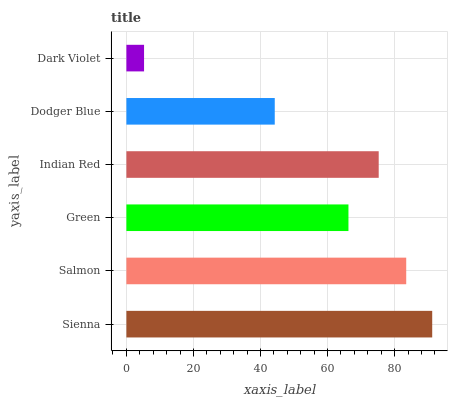Is Dark Violet the minimum?
Answer yes or no. Yes. Is Sienna the maximum?
Answer yes or no. Yes. Is Salmon the minimum?
Answer yes or no. No. Is Salmon the maximum?
Answer yes or no. No. Is Sienna greater than Salmon?
Answer yes or no. Yes. Is Salmon less than Sienna?
Answer yes or no. Yes. Is Salmon greater than Sienna?
Answer yes or no. No. Is Sienna less than Salmon?
Answer yes or no. No. Is Indian Red the high median?
Answer yes or no. Yes. Is Green the low median?
Answer yes or no. Yes. Is Green the high median?
Answer yes or no. No. Is Salmon the low median?
Answer yes or no. No. 